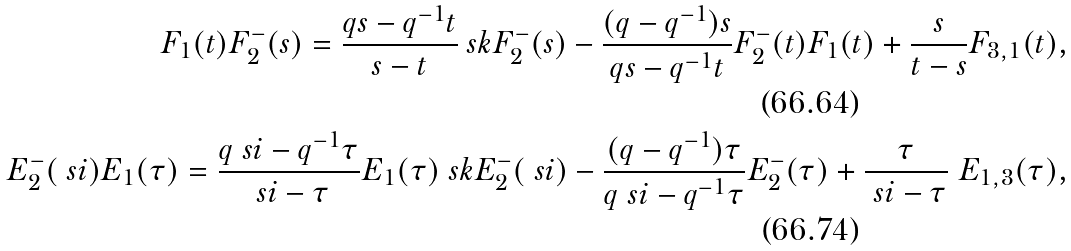Convert formula to latex. <formula><loc_0><loc_0><loc_500><loc_500>F _ { 1 } ( t ) F ^ { - } _ { 2 } ( s ) = \frac { q s - q ^ { - 1 } t } { s - t } \ s k { F _ { 2 } ^ { - } ( s ) - \frac { ( q - q ^ { - 1 } ) s } { q s - q ^ { - 1 } t } F ^ { - } _ { 2 } ( t ) } F _ { 1 } ( t ) + \frac { s } { t - s } F _ { 3 , 1 } ( t ) , \\ E ^ { - } _ { 2 } ( \ s i ) E _ { 1 } ( \tau ) = \frac { q \ s i - q ^ { - 1 } \tau } { \ s i - \tau } E _ { 1 } ( \tau ) \ s k { E _ { 2 } ^ { - } ( \ s i ) - \frac { ( q - q ^ { - 1 } ) \tau } { q \ s i - q ^ { - 1 } \tau } E ^ { - } _ { 2 } ( \tau ) } + \frac { \tau } { \ s i - \tau } \ E _ { 1 , 3 } ( \tau ) ,</formula> 